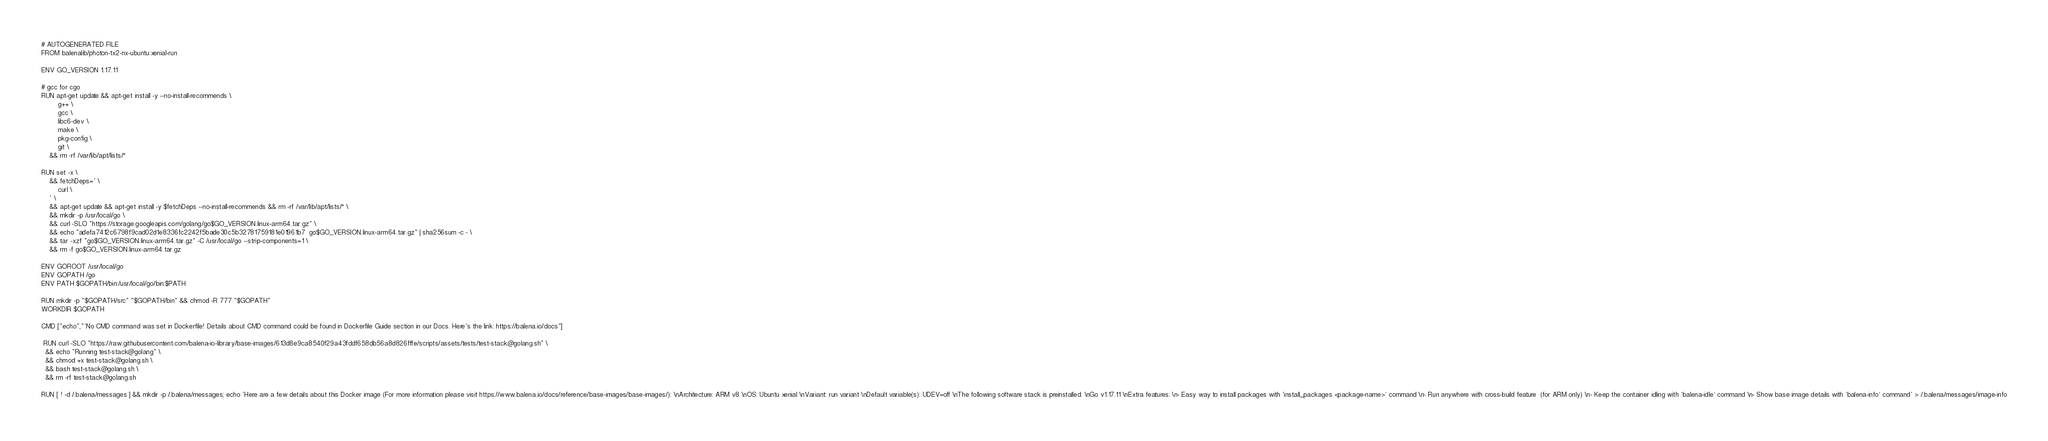<code> <loc_0><loc_0><loc_500><loc_500><_Dockerfile_># AUTOGENERATED FILE
FROM balenalib/photon-tx2-nx-ubuntu:xenial-run

ENV GO_VERSION 1.17.11

# gcc for cgo
RUN apt-get update && apt-get install -y --no-install-recommends \
		g++ \
		gcc \
		libc6-dev \
		make \
		pkg-config \
		git \
	&& rm -rf /var/lib/apt/lists/*

RUN set -x \
	&& fetchDeps=' \
		curl \
	' \
	&& apt-get update && apt-get install -y $fetchDeps --no-install-recommends && rm -rf /var/lib/apt/lists/* \
	&& mkdir -p /usr/local/go \
	&& curl -SLO "https://storage.googleapis.com/golang/go$GO_VERSION.linux-arm64.tar.gz" \
	&& echo "adefa7412c6798f9cad02d1e8336fc2242f5bade30c5b32781759181e01961b7  go$GO_VERSION.linux-arm64.tar.gz" | sha256sum -c - \
	&& tar -xzf "go$GO_VERSION.linux-arm64.tar.gz" -C /usr/local/go --strip-components=1 \
	&& rm -f go$GO_VERSION.linux-arm64.tar.gz

ENV GOROOT /usr/local/go
ENV GOPATH /go
ENV PATH $GOPATH/bin:/usr/local/go/bin:$PATH

RUN mkdir -p "$GOPATH/src" "$GOPATH/bin" && chmod -R 777 "$GOPATH"
WORKDIR $GOPATH

CMD ["echo","'No CMD command was set in Dockerfile! Details about CMD command could be found in Dockerfile Guide section in our Docs. Here's the link: https://balena.io/docs"]

 RUN curl -SLO "https://raw.githubusercontent.com/balena-io-library/base-images/613d8e9ca8540f29a43fddf658db56a8d826fffe/scripts/assets/tests/test-stack@golang.sh" \
  && echo "Running test-stack@golang" \
  && chmod +x test-stack@golang.sh \
  && bash test-stack@golang.sh \
  && rm -rf test-stack@golang.sh 

RUN [ ! -d /.balena/messages ] && mkdir -p /.balena/messages; echo 'Here are a few details about this Docker image (For more information please visit https://www.balena.io/docs/reference/base-images/base-images/): \nArchitecture: ARM v8 \nOS: Ubuntu xenial \nVariant: run variant \nDefault variable(s): UDEV=off \nThe following software stack is preinstalled: \nGo v1.17.11 \nExtra features: \n- Easy way to install packages with `install_packages <package-name>` command \n- Run anywhere with cross-build feature  (for ARM only) \n- Keep the container idling with `balena-idle` command \n- Show base image details with `balena-info` command' > /.balena/messages/image-info</code> 